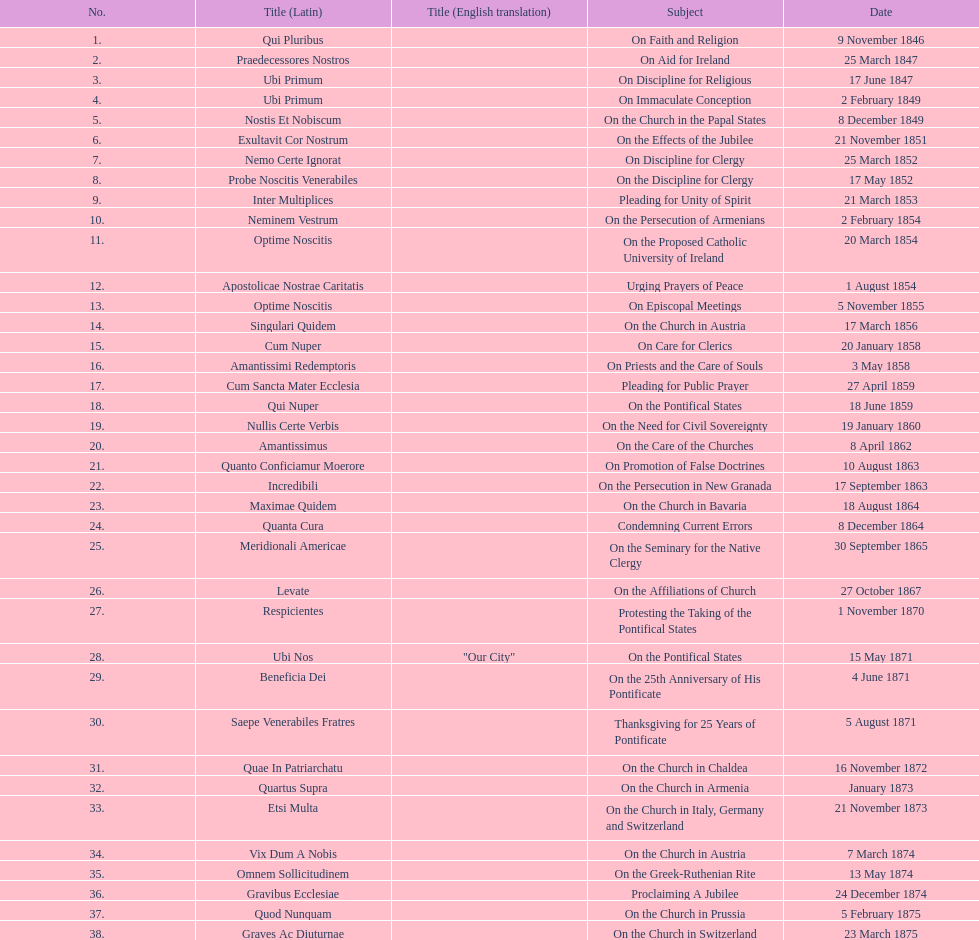Complete sum of encyclicals about churches. 11. 